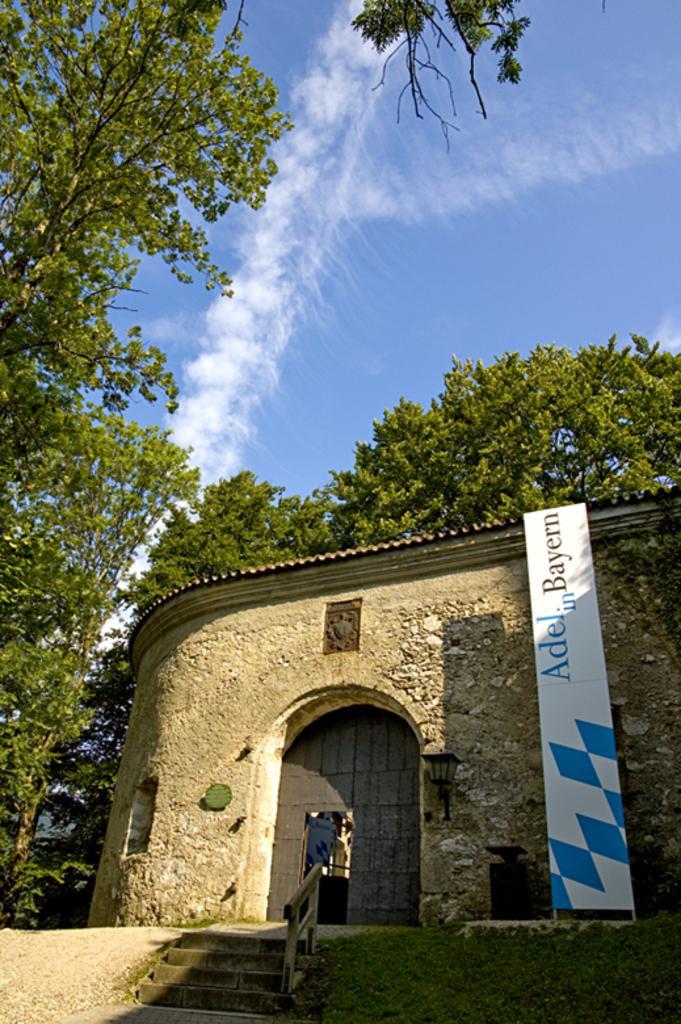In one or two sentences, can you explain what this image depicts? In this image we can see a house, door, steps, hoarding, light on the wall, trees and clouds in the sky. 